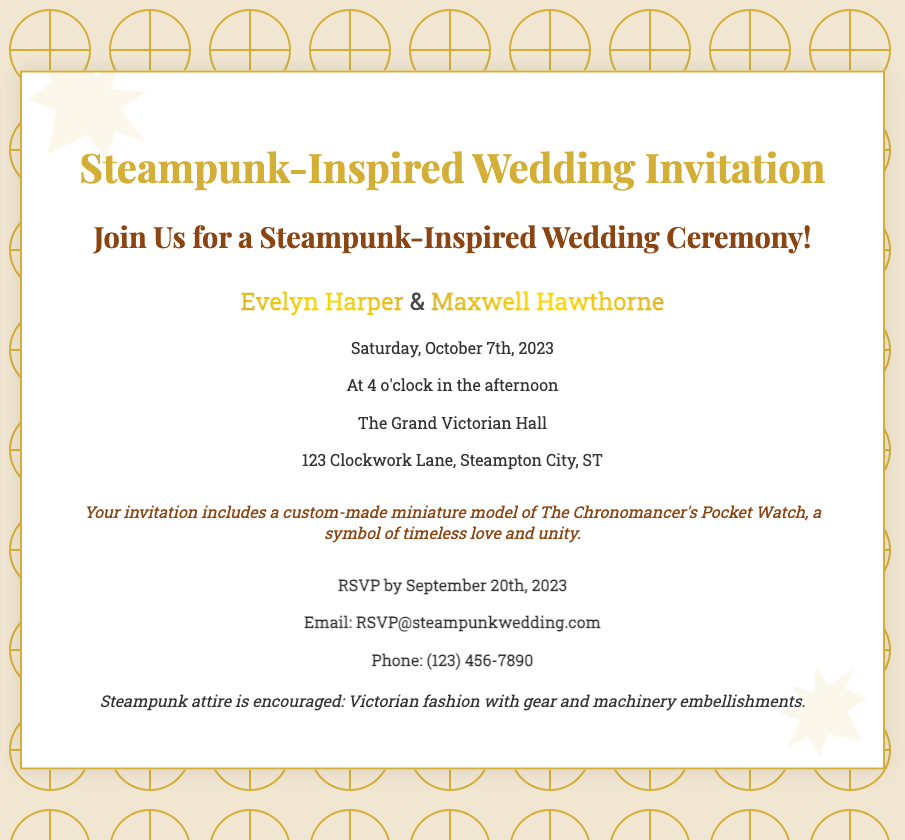What is the couple's names? The couple's names are mentioned in the invitation section, where they are highlighted with a metallic font.
Answer: Evelyn Harper & Maxwell Hawthorne What date is the wedding ceremony? The invitation specifies the date clearly for the wedding ceremony.
Answer: Saturday, October 7th, 2023 What time does the wedding ceremony start? The starting time of the wedding ceremony is stated in the details section.
Answer: 4 o'clock in the afternoon What is the venue for the wedding? The venue is listed in the address section of the invitation.
Answer: The Grand Victorian Hall What is the RSVP date? The RSVP deadline is provided in the RSVP section of the document.
Answer: September 20th, 2023 What item is included with the invitation? The invitation mentions a specific item that is included with it.
Answer: A custom-made miniature model of The Chronomancer's Pocket Watch What type of attire is encouraged? The dress code section specifies what type of attire is encouraged for guests.
Answer: Steampunk attire How many gears are visible in the background? The document mentions two specific gears that are part of the design.
Answer: Two gears 